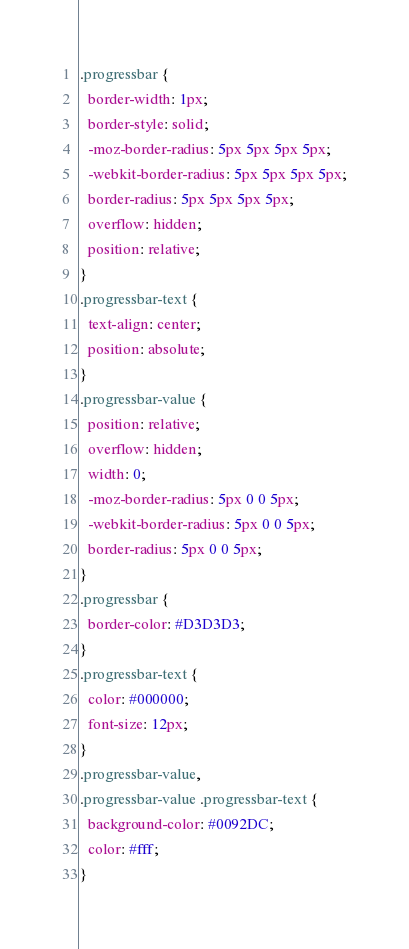Convert code to text. <code><loc_0><loc_0><loc_500><loc_500><_CSS_>.progressbar {
  border-width: 1px;
  border-style: solid;
  -moz-border-radius: 5px 5px 5px 5px;
  -webkit-border-radius: 5px 5px 5px 5px;
  border-radius: 5px 5px 5px 5px;
  overflow: hidden;
  position: relative;
}
.progressbar-text {
  text-align: center;
  position: absolute;
}
.progressbar-value {
  position: relative;
  overflow: hidden;
  width: 0;
  -moz-border-radius: 5px 0 0 5px;
  -webkit-border-radius: 5px 0 0 5px;
  border-radius: 5px 0 0 5px;
}
.progressbar {
  border-color: #D3D3D3;
}
.progressbar-text {
  color: #000000;
  font-size: 12px;
}
.progressbar-value,
.progressbar-value .progressbar-text {
  background-color: #0092DC;
  color: #fff;
}
</code> 